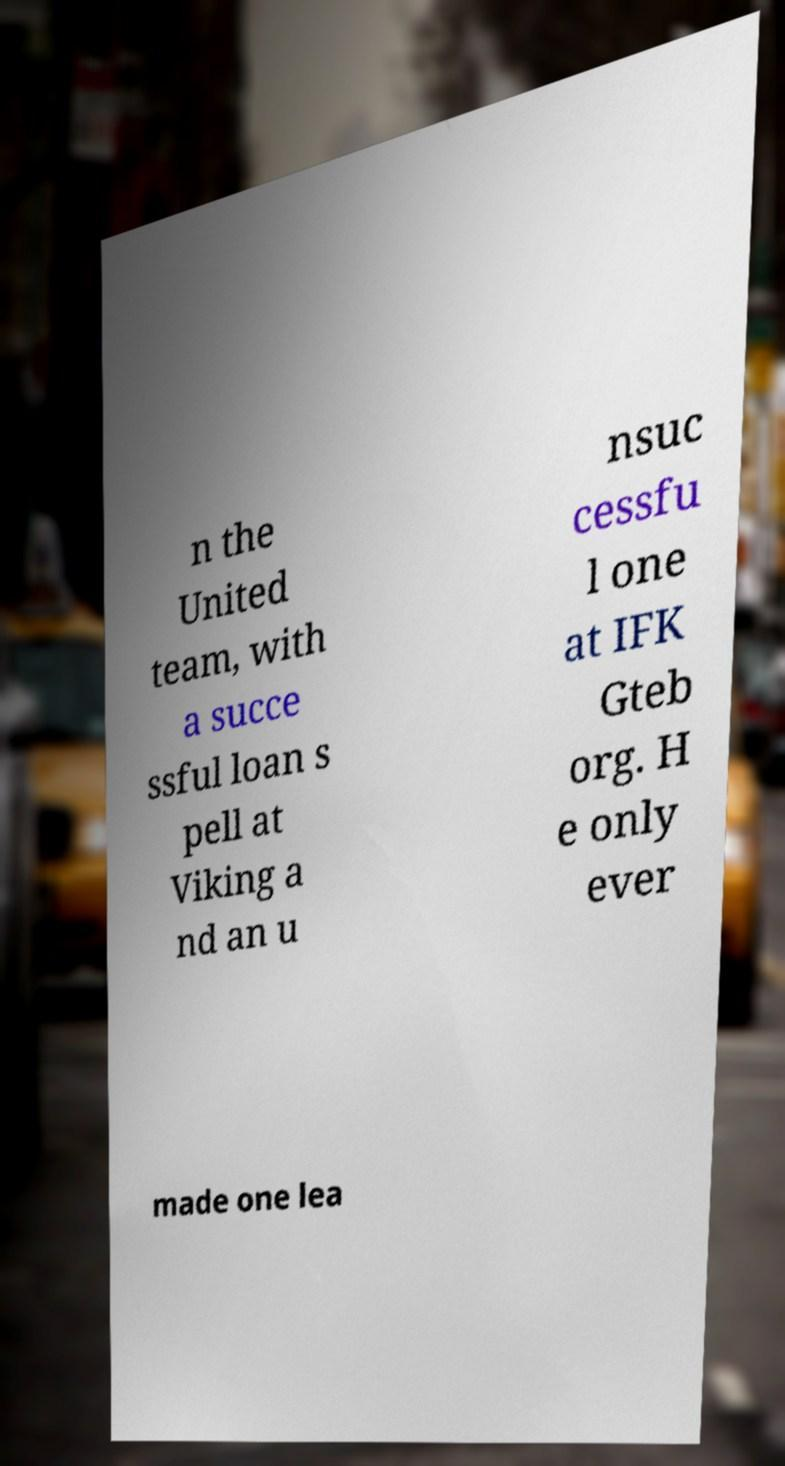Please read and relay the text visible in this image. What does it say? n the United team, with a succe ssful loan s pell at Viking a nd an u nsuc cessfu l one at IFK Gteb org. H e only ever made one lea 